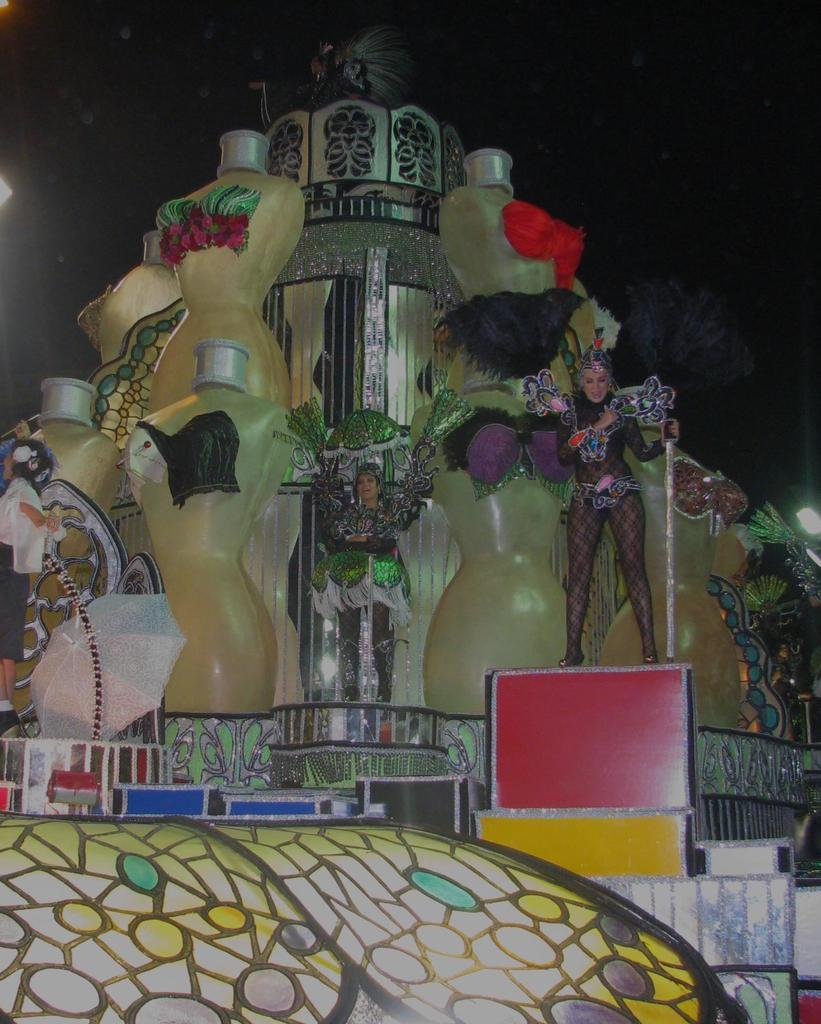What can be seen in the image? There are women standing in the image, wearing costumes. What else is present in the image? There are lights, statues, a building, and the sky visible in the image. Can you describe the building in the image? The building in the image is not specified, but it is mentioned as being present. What might the lights be used for in the image? The lights could be used for illumination or decoration in the image. How many bikes are parked near the women in the image? There is no mention of bikes in the image, so it cannot be determined how many might be present. 